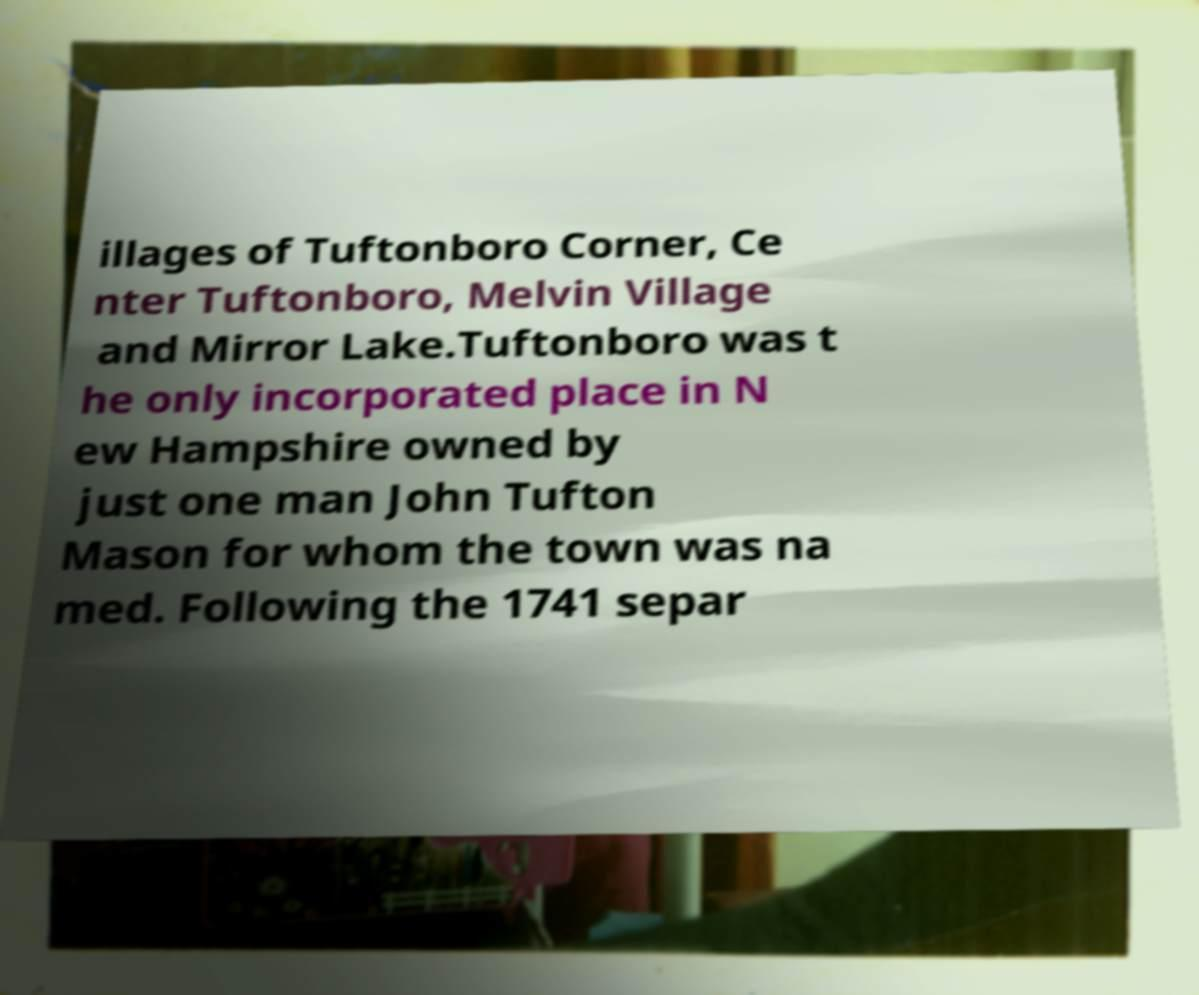Can you accurately transcribe the text from the provided image for me? illages of Tuftonboro Corner, Ce nter Tuftonboro, Melvin Village and Mirror Lake.Tuftonboro was t he only incorporated place in N ew Hampshire owned by just one man John Tufton Mason for whom the town was na med. Following the 1741 separ 